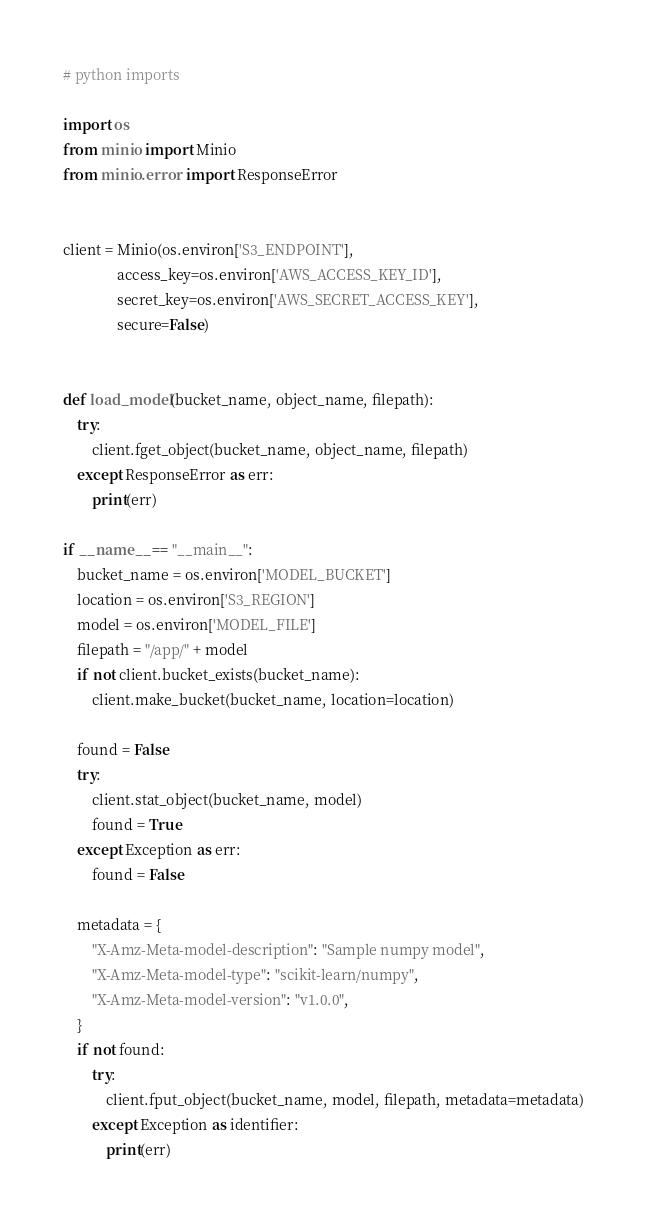<code> <loc_0><loc_0><loc_500><loc_500><_Python_>
# python imports

import os
from minio import Minio
from minio.error import ResponseError


client = Minio(os.environ['S3_ENDPOINT'],
               access_key=os.environ['AWS_ACCESS_KEY_ID'],
               secret_key=os.environ['AWS_SECRET_ACCESS_KEY'],
               secure=False)


def load_model(bucket_name, object_name, filepath):
    try:
        client.fget_object(bucket_name, object_name, filepath)
    except ResponseError as err:
        print(err)

if __name__ == "__main__":
    bucket_name = os.environ['MODEL_BUCKET']
    location = os.environ['S3_REGION']
    model = os.environ['MODEL_FILE']
    filepath = "/app/" + model
    if not client.bucket_exists(bucket_name):
        client.make_bucket(bucket_name, location=location)

    found = False
    try:
        client.stat_object(bucket_name, model)
        found = True
    except Exception as err:
        found = False

    metadata = {
        "X-Amz-Meta-model-description": "Sample numpy model",
        "X-Amz-Meta-model-type": "scikit-learn/numpy",
        "X-Amz-Meta-model-version": "v1.0.0",
    }
    if not found:
        try:
            client.fput_object(bucket_name, model, filepath, metadata=metadata)
        except Exception as identifier:
            print(err)
</code> 